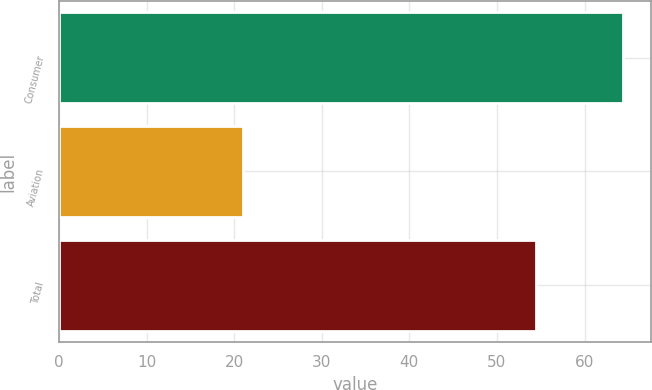Convert chart to OTSL. <chart><loc_0><loc_0><loc_500><loc_500><bar_chart><fcel>Consumer<fcel>Aviation<fcel>Total<nl><fcel>64.4<fcel>21<fcel>54.5<nl></chart> 